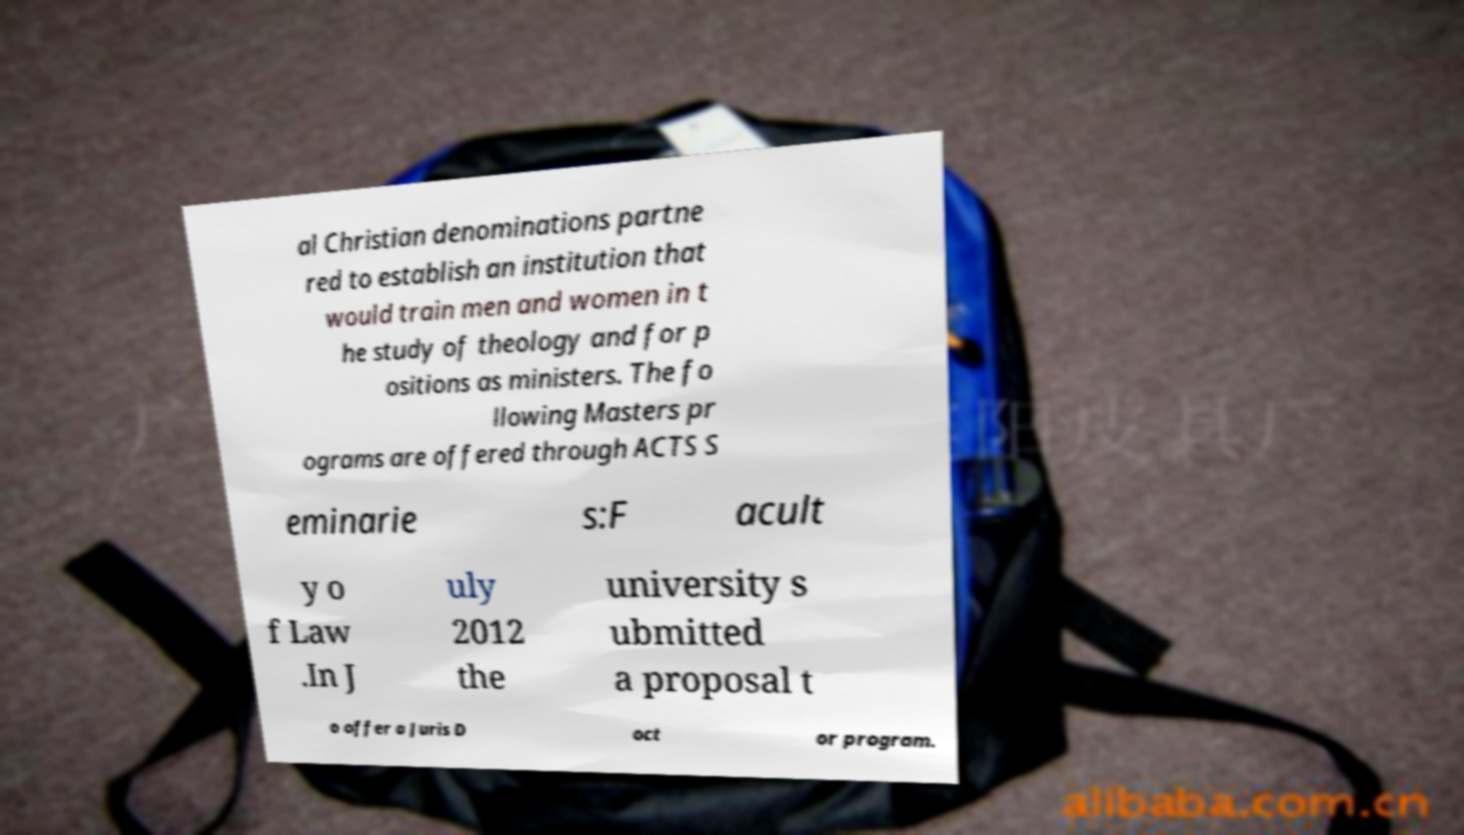There's text embedded in this image that I need extracted. Can you transcribe it verbatim? al Christian denominations partne red to establish an institution that would train men and women in t he study of theology and for p ositions as ministers. The fo llowing Masters pr ograms are offered through ACTS S eminarie s:F acult y o f Law .In J uly 2012 the university s ubmitted a proposal t o offer a Juris D oct or program. 